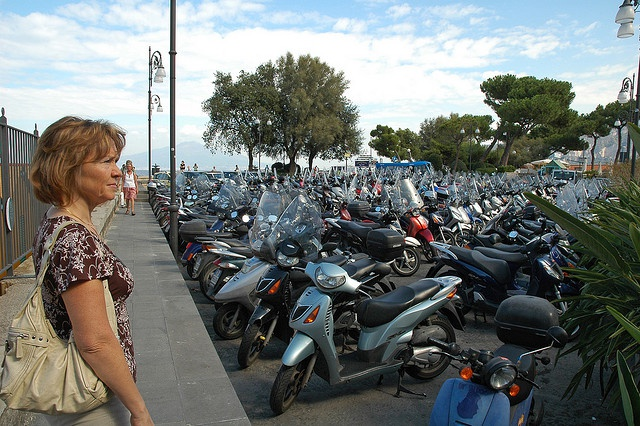Describe the objects in this image and their specific colors. I can see people in lightblue, gray, black, and maroon tones, handbag in lightblue, tan, gray, and black tones, motorcycle in lightblue, black, gray, and purple tones, potted plant in lightblue, black, darkgreen, and gray tones, and motorcycle in lightblue, black, blue, gray, and navy tones in this image. 